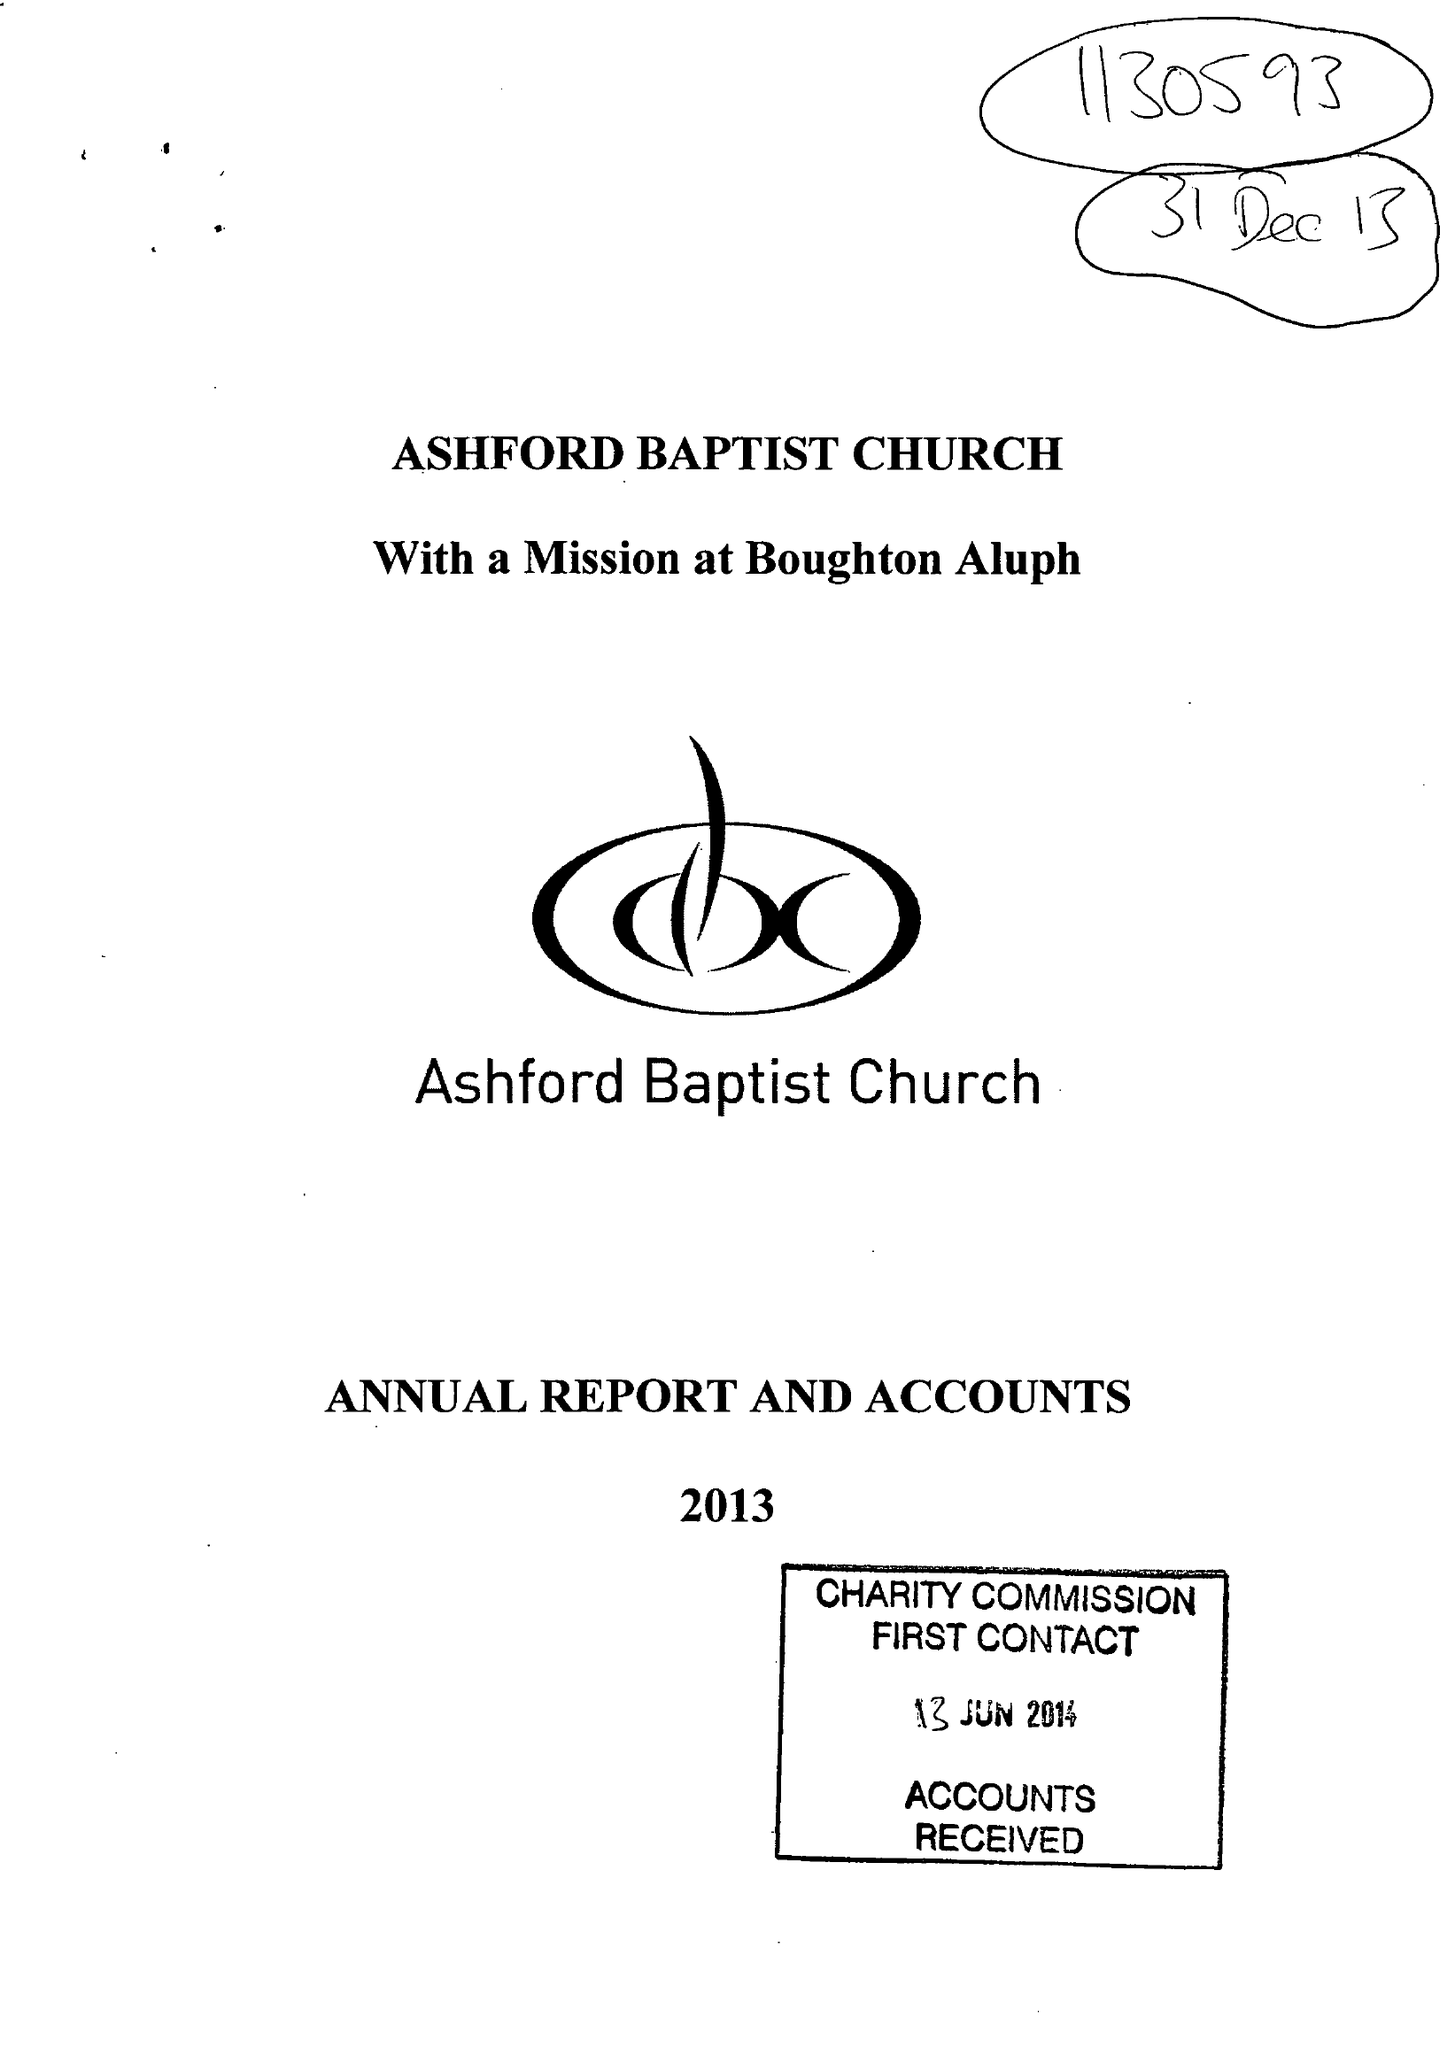What is the value for the charity_number?
Answer the question using a single word or phrase. 1130593 